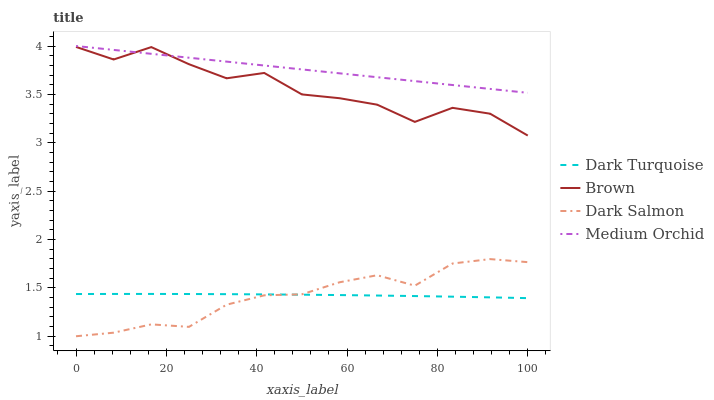Does Dark Salmon have the minimum area under the curve?
Answer yes or no. Yes. Does Medium Orchid have the maximum area under the curve?
Answer yes or no. Yes. Does Medium Orchid have the minimum area under the curve?
Answer yes or no. No. Does Dark Salmon have the maximum area under the curve?
Answer yes or no. No. Is Medium Orchid the smoothest?
Answer yes or no. Yes. Is Brown the roughest?
Answer yes or no. Yes. Is Dark Salmon the smoothest?
Answer yes or no. No. Is Dark Salmon the roughest?
Answer yes or no. No. Does Dark Salmon have the lowest value?
Answer yes or no. Yes. Does Medium Orchid have the lowest value?
Answer yes or no. No. Does Medium Orchid have the highest value?
Answer yes or no. Yes. Does Dark Salmon have the highest value?
Answer yes or no. No. Is Dark Turquoise less than Medium Orchid?
Answer yes or no. Yes. Is Brown greater than Dark Turquoise?
Answer yes or no. Yes. Does Dark Salmon intersect Dark Turquoise?
Answer yes or no. Yes. Is Dark Salmon less than Dark Turquoise?
Answer yes or no. No. Is Dark Salmon greater than Dark Turquoise?
Answer yes or no. No. Does Dark Turquoise intersect Medium Orchid?
Answer yes or no. No. 